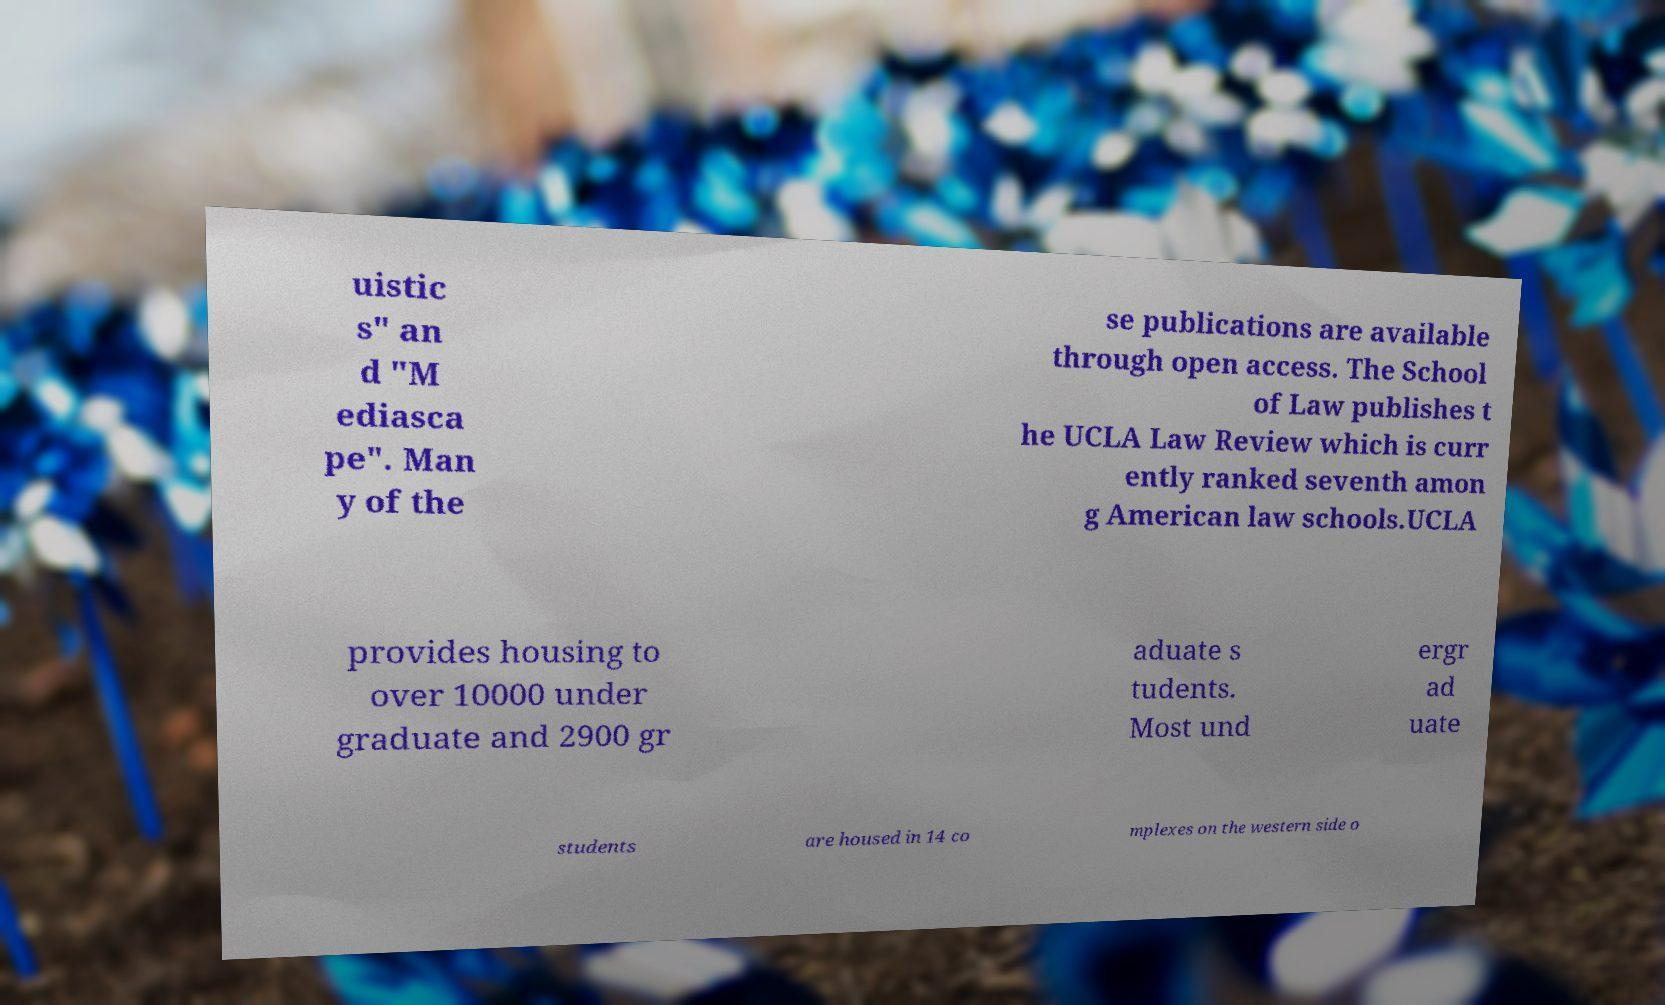Could you assist in decoding the text presented in this image and type it out clearly? uistic s" an d "M ediasca pe". Man y of the se publications are available through open access. The School of Law publishes t he UCLA Law Review which is curr ently ranked seventh amon g American law schools.UCLA provides housing to over 10000 under graduate and 2900 gr aduate s tudents. Most und ergr ad uate students are housed in 14 co mplexes on the western side o 